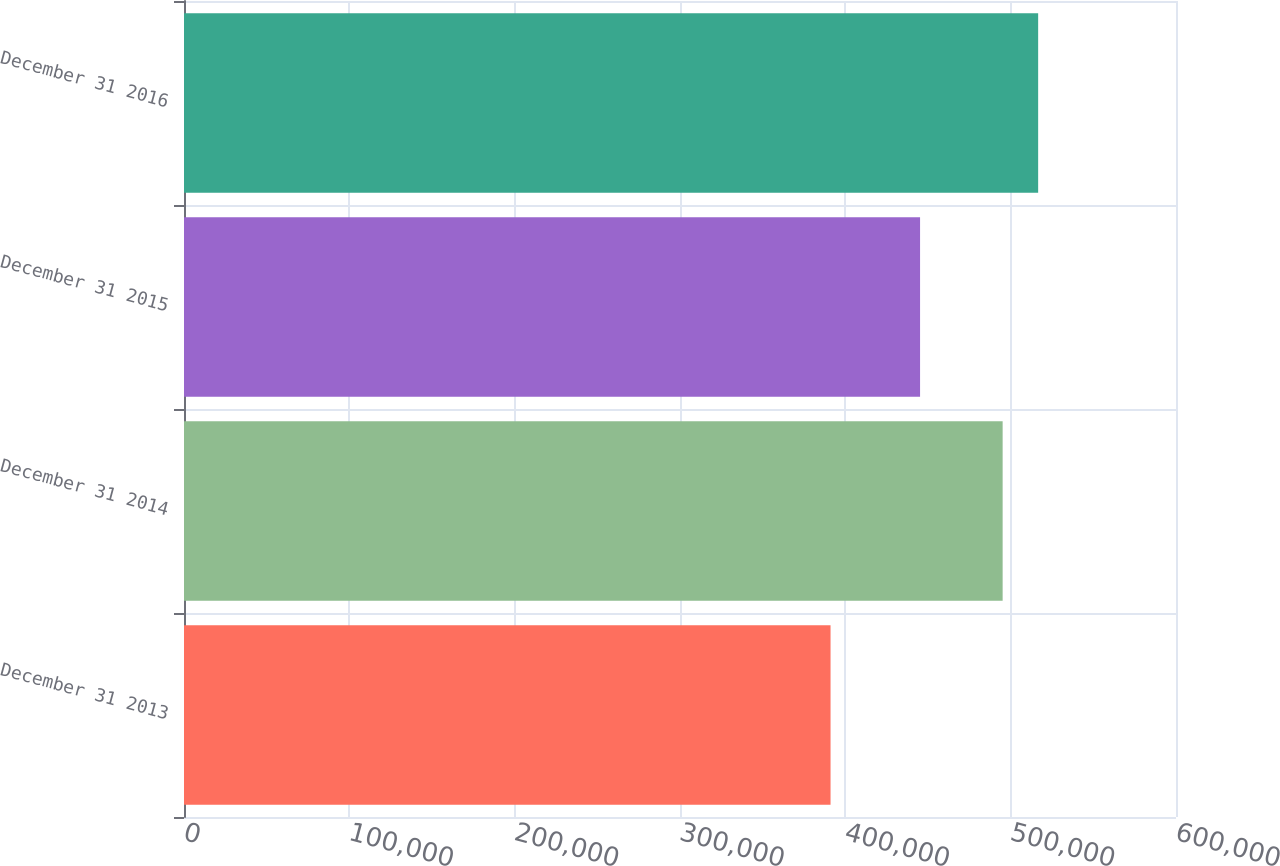Convert chart. <chart><loc_0><loc_0><loc_500><loc_500><bar_chart><fcel>December 31 2013<fcel>December 31 2014<fcel>December 31 2015<fcel>December 31 2016<nl><fcel>391056<fcel>495148<fcel>445202<fcel>516625<nl></chart> 